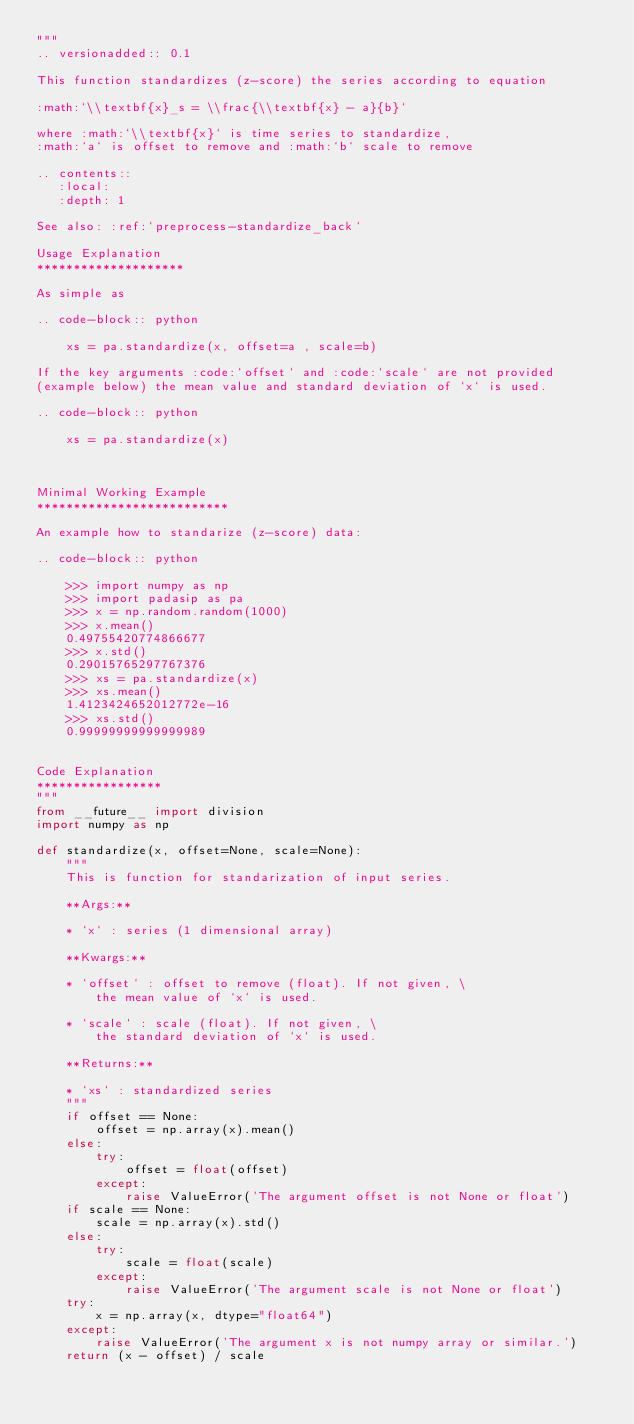<code> <loc_0><loc_0><loc_500><loc_500><_Python_>"""
.. versionadded:: 0.1

This function standardizes (z-score) the series according to equation

:math:`\\textbf{x}_s = \\frac{\\textbf{x} - a}{b}`

where :math:`\\textbf{x}` is time series to standardize,
:math:`a` is offset to remove and :math:`b` scale to remove

.. contents::
   :local:
   :depth: 1

See also: :ref:`preprocess-standardize_back`

Usage Explanation
********************

As simple as

.. code-block:: python

    xs = pa.standardize(x, offset=a , scale=b)

If the key arguments :code:`offset` and :code:`scale` are not provided
(example below) the mean value and standard deviation of `x` is used. 

.. code-block:: python

    xs = pa.standardize(x)


 
Minimal Working Example
**************************

An example how to standarize (z-score) data:

.. code-block:: python

    >>> import numpy as np
    >>> import padasip as pa
    >>> x = np.random.random(1000)
    >>> x.mean()
    0.49755420774866677
    >>> x.std()
    0.29015765297767376
    >>> xs = pa.standardize(x)
    >>> xs.mean()
    1.4123424652012772e-16
    >>> xs.std()
    0.99999999999999989


Code Explanation
***************** 
"""
from __future__ import division
import numpy as np

def standardize(x, offset=None, scale=None):
    """   
    This is function for standarization of input series.

    **Args:**

    * `x` : series (1 dimensional array)

    **Kwargs:**

    * `offset` : offset to remove (float). If not given, \
        the mean value of `x` is used.

    * `scale` : scale (float). If not given, \
        the standard deviation of `x` is used.
        
    **Returns:**

    * `xs` : standardized series
    """
    if offset == None:
        offset = np.array(x).mean()
    else:
        try:
            offset = float(offset)
        except:
            raise ValueError('The argument offset is not None or float') 
    if scale == None:
        scale = np.array(x).std()
    else:
        try:
            scale = float(scale)
        except:
            raise ValueError('The argument scale is not None or float')    
    try:
        x = np.array(x, dtype="float64")
    except:
        raise ValueError('The argument x is not numpy array or similar.')         
    return (x - offset) / scale
</code> 